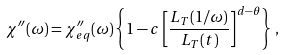<formula> <loc_0><loc_0><loc_500><loc_500>\chi ^ { \prime \prime } ( \omega ) = \chi _ { e q } ^ { \prime \prime } ( \omega ) \left \{ 1 - c \left [ \frac { L _ { T } ( 1 / \omega ) } { L _ { T } ( t ) } \right ] ^ { d - \theta } \right \} \, ,</formula> 